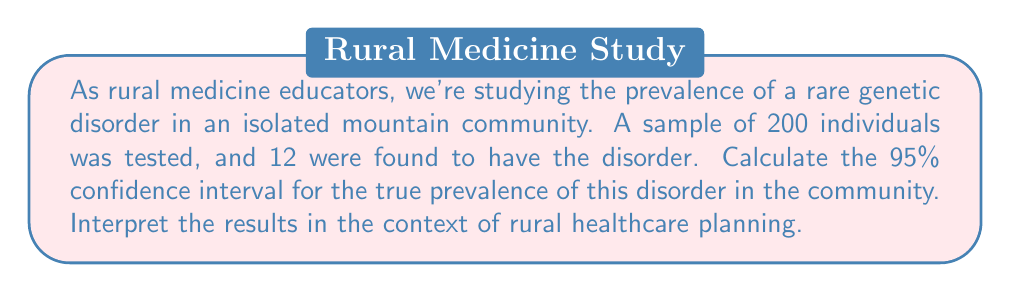Teach me how to tackle this problem. Let's approach this step-by-step:

1) First, we calculate the point estimate of the prevalence:
   $\hat{p} = \frac{12}{200} = 0.06$ or 6%

2) For a 95% confidence interval, we use the formula:
   $$CI = \hat{p} \pm z_{\alpha/2} \sqrt{\frac{\hat{p}(1-\hat{p})}{n}}$$
   where $z_{\alpha/2} = 1.96$ for a 95% CI

3) Calculate the standard error:
   $$SE = \sqrt{\frac{0.06(1-0.06)}{200}} = \sqrt{\frac{0.0564}{200}} = 0.0168$$

4) Now we can calculate the margin of error:
   $$ME = 1.96 \times 0.0168 = 0.0329$$

5) The confidence interval is then:
   $$0.06 \pm 0.0329$$
   $$(0.0271, 0.0929)$$ or (2.71%, 9.29%)

Interpretation: We can be 95% confident that the true prevalence of the genetic disorder in this isolated mountain community lies between 2.71% and 9.29%. This wide interval reflects the uncertainty due to the small sample size, which is common in rural and isolated communities.

For rural healthcare planning, this information suggests that:
1) The disorder is present in the community and warrants attention.
2) The prevalence could be as low as about 3% or as high as about 9%, which is a significant range.
3) Further testing might be needed to narrow this range and make more precise healthcare decisions.
4) Resources should be allocated for genetic counseling and potential treatment, but the exact scale of the program remains uncertain.
5) Collaboration with other rural communities might be beneficial to increase the sample size and improve precision of the estimate.
Answer: 95% CI: (2.71%, 9.29%); Interpretation: True prevalence likely between 2.71% and 9.29%, indicating presence of disorder but with considerable uncertainty, necessitating careful resource allocation and possibly further testing. 